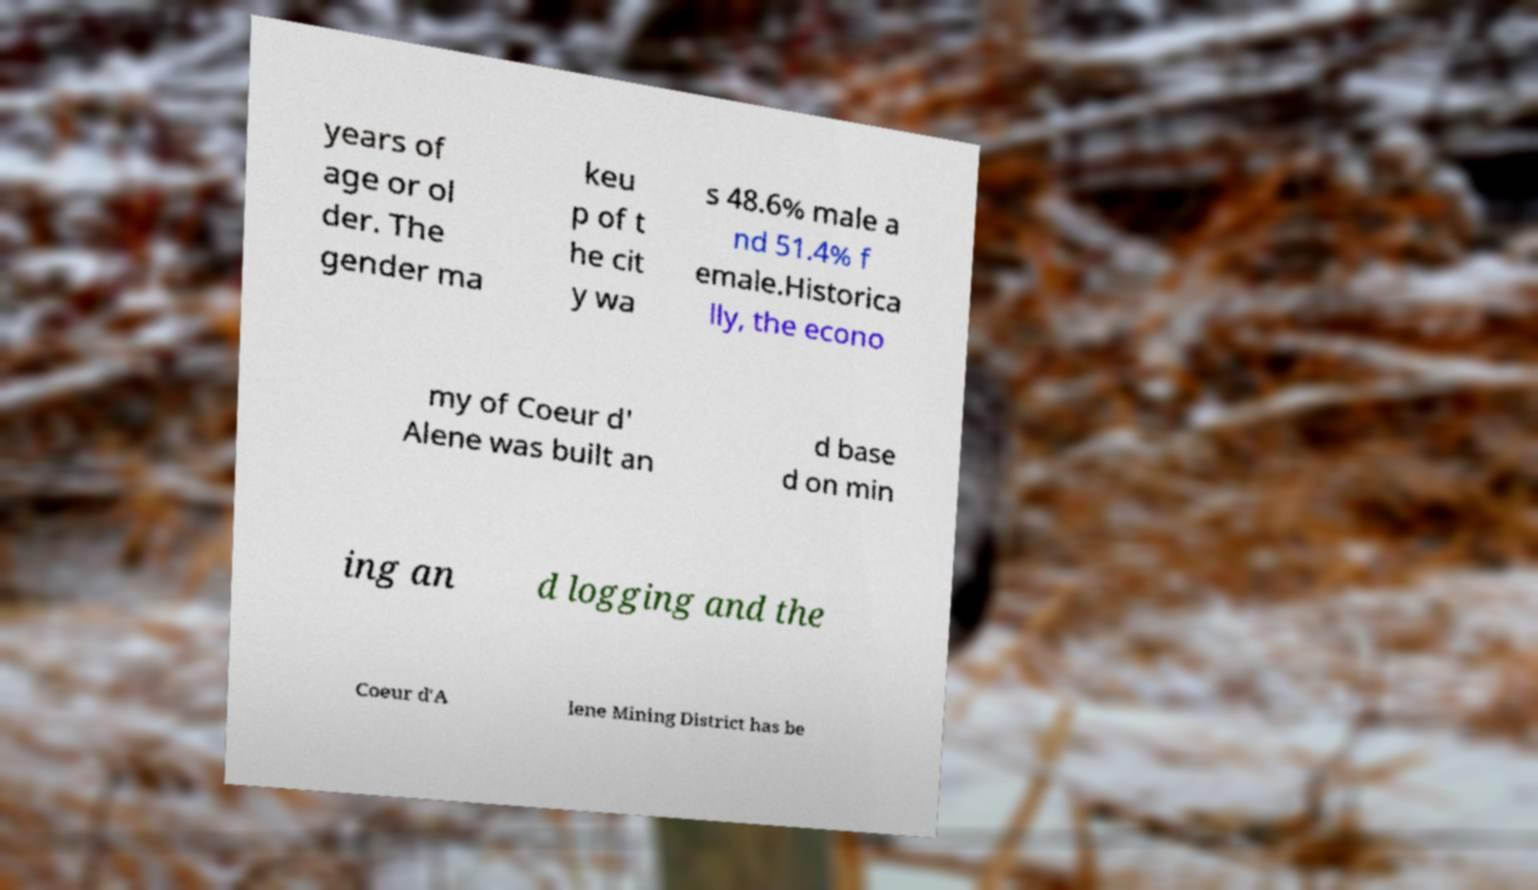Can you read and provide the text displayed in the image?This photo seems to have some interesting text. Can you extract and type it out for me? years of age or ol der. The gender ma keu p of t he cit y wa s 48.6% male a nd 51.4% f emale.Historica lly, the econo my of Coeur d' Alene was built an d base d on min ing an d logging and the Coeur d'A lene Mining District has be 